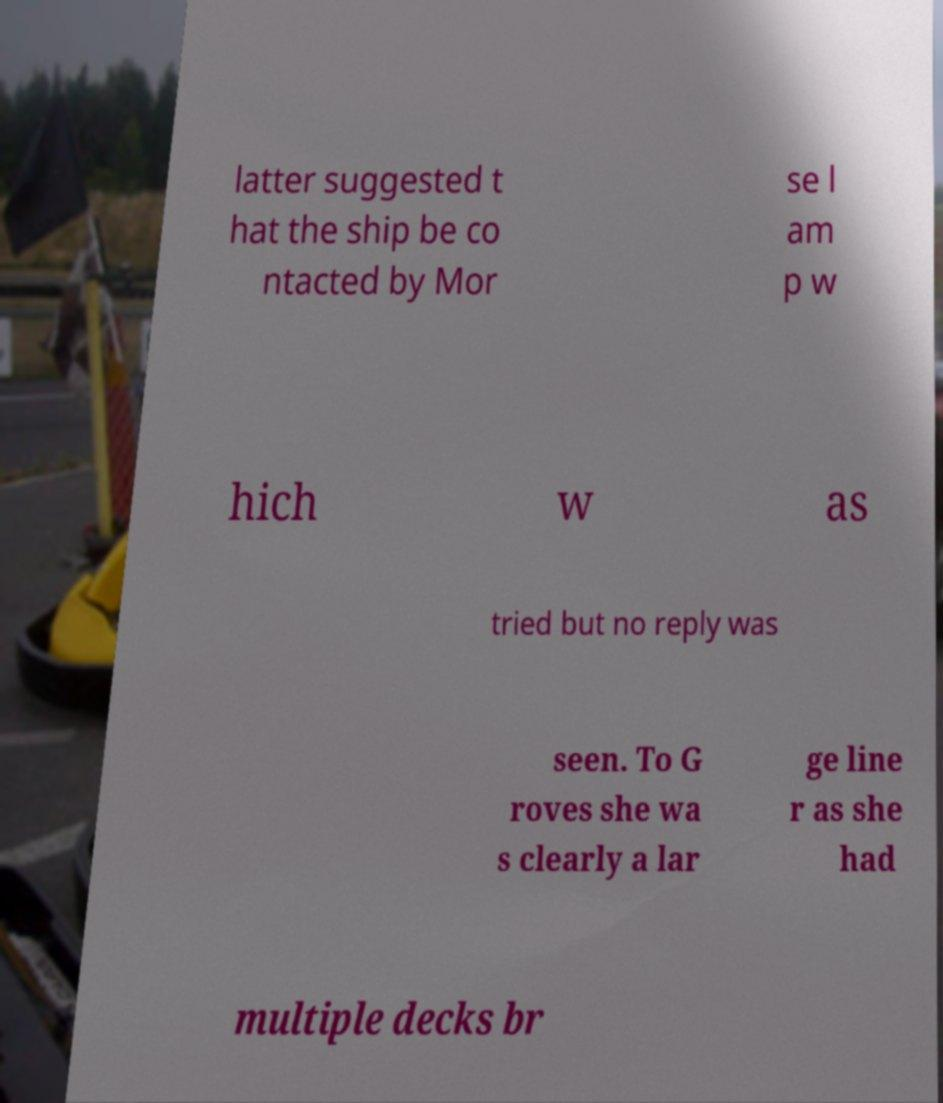For documentation purposes, I need the text within this image transcribed. Could you provide that? latter suggested t hat the ship be co ntacted by Mor se l am p w hich w as tried but no reply was seen. To G roves she wa s clearly a lar ge line r as she had multiple decks br 